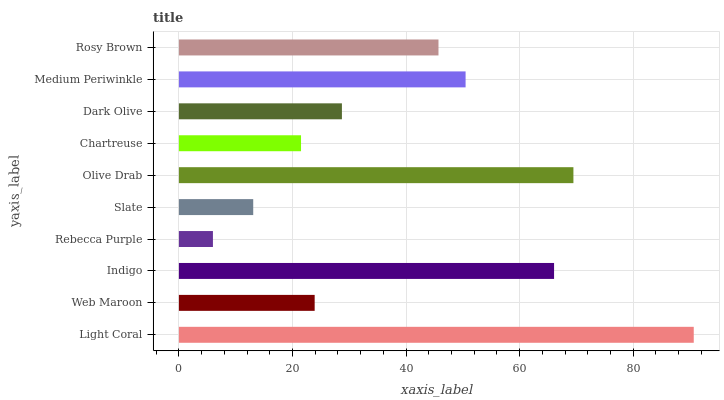Is Rebecca Purple the minimum?
Answer yes or no. Yes. Is Light Coral the maximum?
Answer yes or no. Yes. Is Web Maroon the minimum?
Answer yes or no. No. Is Web Maroon the maximum?
Answer yes or no. No. Is Light Coral greater than Web Maroon?
Answer yes or no. Yes. Is Web Maroon less than Light Coral?
Answer yes or no. Yes. Is Web Maroon greater than Light Coral?
Answer yes or no. No. Is Light Coral less than Web Maroon?
Answer yes or no. No. Is Rosy Brown the high median?
Answer yes or no. Yes. Is Dark Olive the low median?
Answer yes or no. Yes. Is Light Coral the high median?
Answer yes or no. No. Is Light Coral the low median?
Answer yes or no. No. 